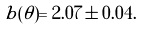Convert formula to latex. <formula><loc_0><loc_0><loc_500><loc_500>b ( \theta ) = 2 . 0 7 \pm 0 . 0 4 .</formula> 